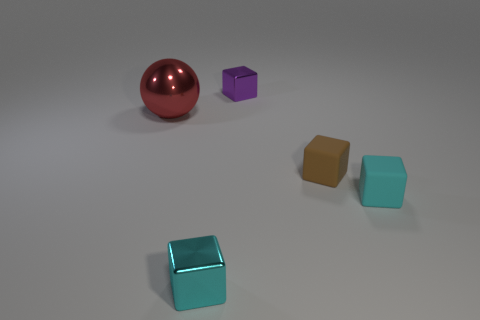Add 3 large cyan things. How many objects exist? 8 Subtract all blocks. How many objects are left? 1 Subtract 0 gray cubes. How many objects are left? 5 Subtract all brown cubes. Subtract all big red objects. How many objects are left? 3 Add 5 large red metallic things. How many large red metallic things are left? 6 Add 5 tiny red metallic things. How many tiny red metallic things exist? 5 